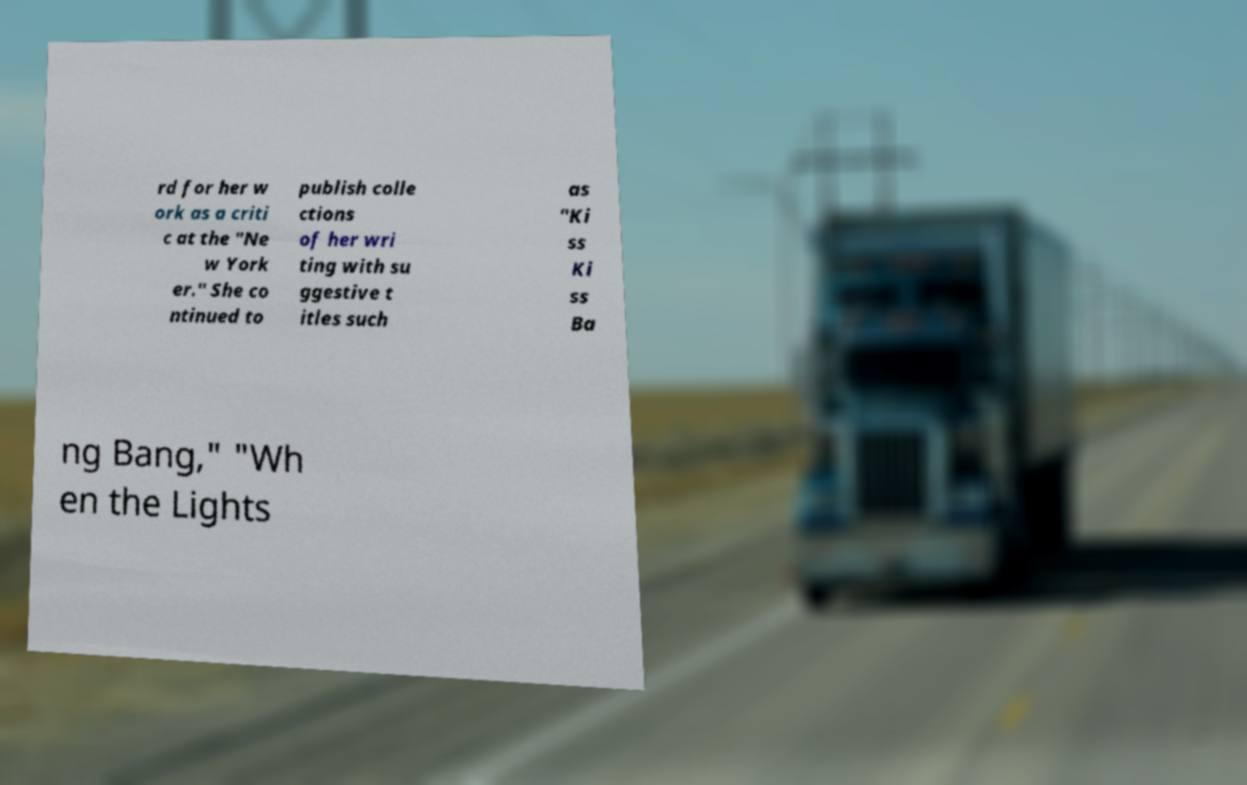I need the written content from this picture converted into text. Can you do that? rd for her w ork as a criti c at the "Ne w York er." She co ntinued to publish colle ctions of her wri ting with su ggestive t itles such as "Ki ss Ki ss Ba ng Bang," "Wh en the Lights 